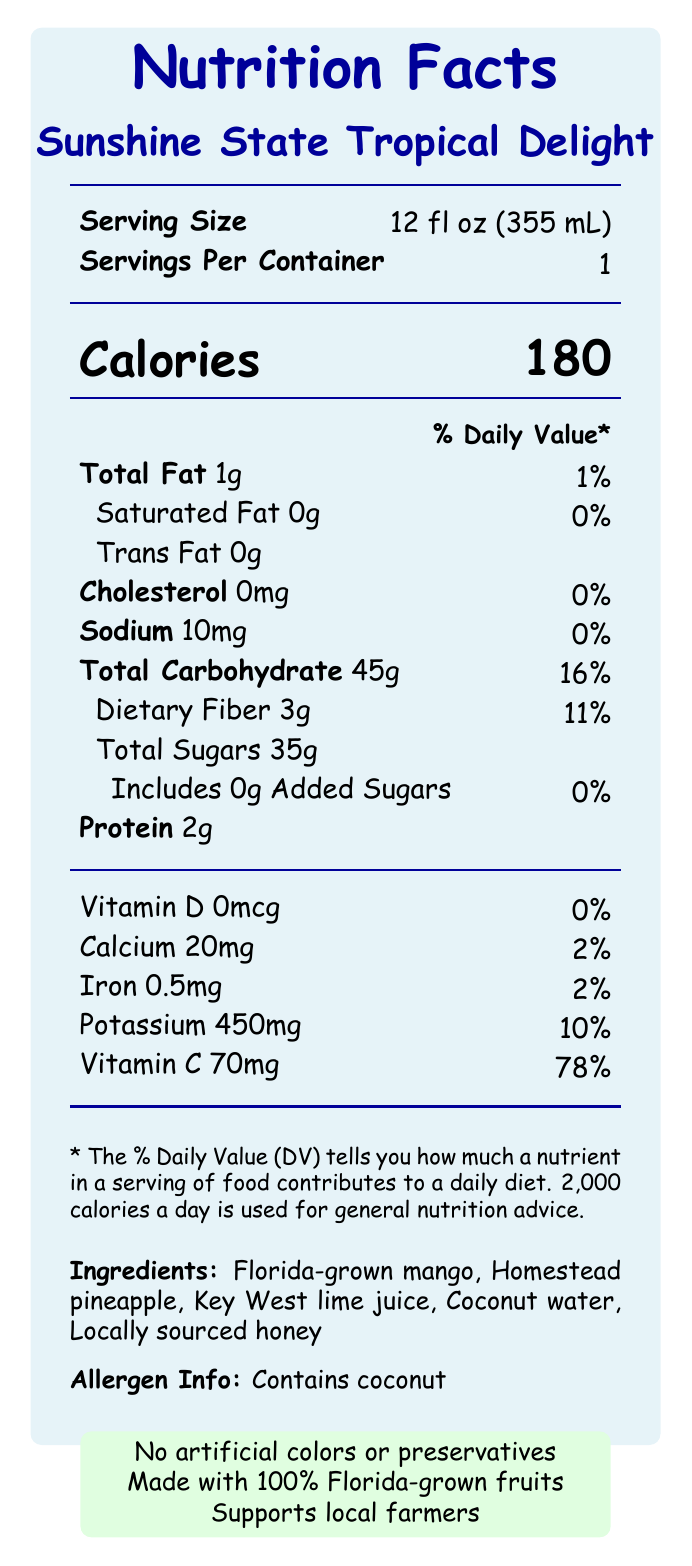what is the serving size for Sunshine State Tropical Delight? The serving size is mentioned as "12 fl oz (355 mL)" on the label.
Answer: 12 fl oz (355 mL) how many grams of dietary fiber does one serving contain? The dietary fiber content is listed as "3g" on the nutrition facts label.
Answer: 3g what is the percentage of daily value of Vitamin C in a serving? The daily value percentage for Vitamin C is listed as "78%" on the label.
Answer: 78% what are the main ingredients of Sunshine State Tropical Delight? These ingredients are listed under the "Ingredients" section of the label.
Answer: Florida-grown mango, Homestead pineapple, Key West lime juice, Coconut water, Locally sourced honey does the product contain any added sugars? The label shows that it contains "0g" of added sugars.
Answer: No how many calories are in a serving of Sunshine State Tropical Delight? The document lists the calorie count per serving as "180" on the label.
Answer: 180 How much potassium does a serving have? The potassium content is stated as "450 mg" on the nutrition facts label.
Answer: 450 mg which nutrient has the highest percentage of daily value in a serving? The nutrient with the highest percentage daily value is Vitamin C at "78%".
Answer: Vitamin C what is the total carbohydrate content and its daily value percentage? The total carbohydrate content is "45g" with a daily value percentage of "16%".
Answer: 45g, 16% which of the following claims are made for the Sunshine State Tropical Delight? A. Contains artificial preservatives B. Made with 100% Florida-grown fruits C. Supports local farmers The claims "Made with 100% Florida-grown fruits" and "Supports local farmers" are listed on the label.
Answer: B, C What should the consumer do after opening the bottle of Sunshine State Tropical Delight? A. Store in the pantry B. Freeze it C. Keep refrigerated and consume within 3 days The storage instructions say to "Keep refrigerated and consume within 3 days of opening."
Answer: C Is this drink suitable for people with coconut allergies? The allergen information clearly states that the product "Contains coconut."
Answer: No summarize the document. The document comprehensively lists nutritional information, ingredients, and special features of the smoothie, emphasizing local sourcing and senior-friendly design aspects.
Answer: The document provides detailed nutrition facts, ingredients, health claims, and storage instructions for the "Sunshine State Tropical Delight" smoothie, crafted with Florida-grown produce and local ingredients. It highlights nutrient values, allergen information, sustainability notes, and senior-friendly features. where is the smoothie processed? The document mentions it's crafted in small batches at their Little Havana smoothie shop.
Answer: Little Havana what is the source of added sweetness in this product? The document does not specify where the natural sweetness comes from beyond listing "Locally sourced honey" as an ingredient, but it does confirm there are no added sugars.
Answer: Not enough information what makes this smoothie gentle on sensitive stomachs? One of the listed senior-friendly features includes that it is "Gentle on sensitive stomachs."
Answer: Senior-friendly feature 